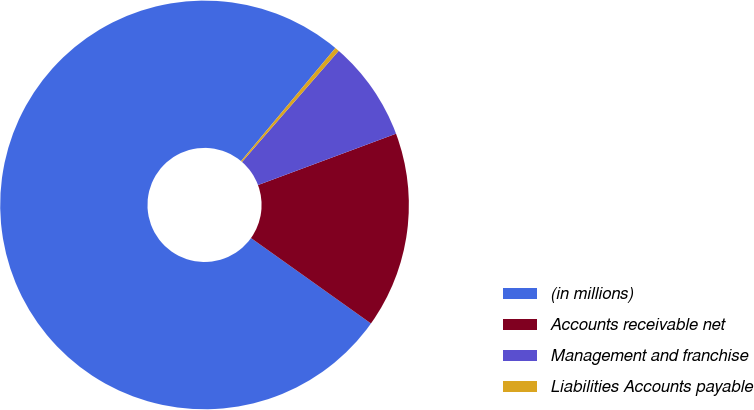Convert chart. <chart><loc_0><loc_0><loc_500><loc_500><pie_chart><fcel>(in millions)<fcel>Accounts receivable net<fcel>Management and franchise<fcel>Liabilities Accounts payable<nl><fcel>76.22%<fcel>15.52%<fcel>7.93%<fcel>0.34%<nl></chart> 